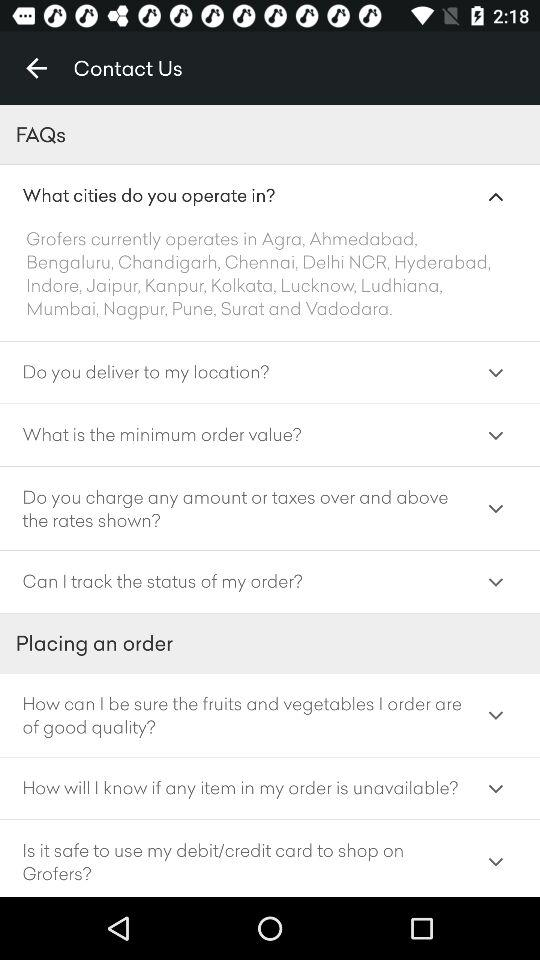In which cities does "Grofers" operate? "Grofers" operates in Agra, Ahmedabad, Bengaluru, Chandigarh, Chennai, Delhi-NCR, Hyderabad, Indore, Jaipur, Kanpur, Kolkata, Lucknow, Ludhiana, Mumbai, Nagpur, Pune, Surat and Vadodara. 